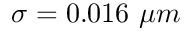<formula> <loc_0><loc_0><loc_500><loc_500>\sigma = 0 . 0 1 6 \mu m</formula> 